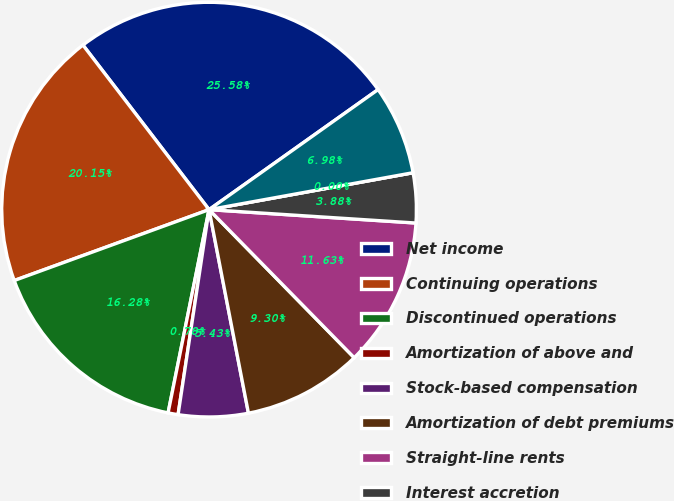<chart> <loc_0><loc_0><loc_500><loc_500><pie_chart><fcel>Net income<fcel>Continuing operations<fcel>Discontinued operations<fcel>Amortization of above and<fcel>Stock-based compensation<fcel>Amortization of debt premiums<fcel>Straight-line rents<fcel>Interest accretion<fcel>Deferred rental revenue<fcel>Equity income from<nl><fcel>25.58%<fcel>20.15%<fcel>16.28%<fcel>0.78%<fcel>5.43%<fcel>9.3%<fcel>11.63%<fcel>3.88%<fcel>0.0%<fcel>6.98%<nl></chart> 